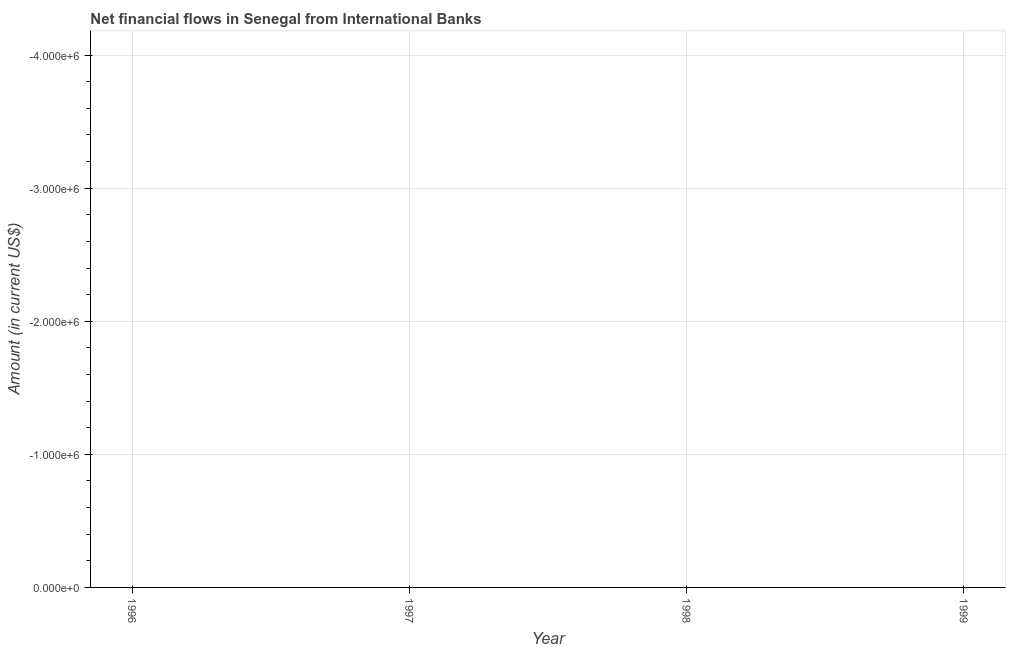What is the net financial flows from ibrd in 1998?
Make the answer very short. 0. Across all years, what is the minimum net financial flows from ibrd?
Provide a succinct answer. 0. What is the sum of the net financial flows from ibrd?
Your answer should be compact. 0. What is the median net financial flows from ibrd?
Your answer should be compact. 0. Does the net financial flows from ibrd monotonically increase over the years?
Ensure brevity in your answer.  Yes. How many dotlines are there?
Keep it short and to the point. 0. What is the title of the graph?
Make the answer very short. Net financial flows in Senegal from International Banks. What is the Amount (in current US$) in 1997?
Your answer should be compact. 0. What is the Amount (in current US$) in 1998?
Your answer should be compact. 0. What is the Amount (in current US$) in 1999?
Provide a short and direct response. 0. 